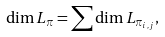Convert formula to latex. <formula><loc_0><loc_0><loc_500><loc_500>\dim L _ { \pi } = \sum \dim L _ { \pi _ { i , j } } ,</formula> 